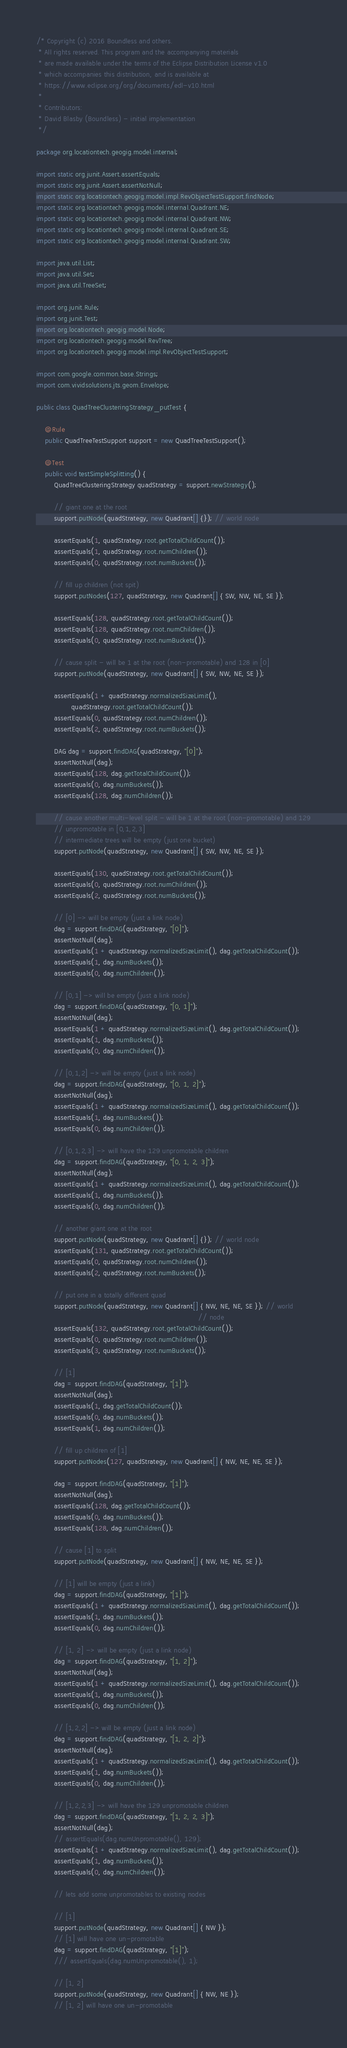<code> <loc_0><loc_0><loc_500><loc_500><_Java_>/* Copyright (c) 2016 Boundless and others.
 * All rights reserved. This program and the accompanying materials
 * are made available under the terms of the Eclipse Distribution License v1.0
 * which accompanies this distribution, and is available at
 * https://www.eclipse.org/org/documents/edl-v10.html
 *
 * Contributors:
 * David Blasby (Boundless) - initial implementation
 */

package org.locationtech.geogig.model.internal;

import static org.junit.Assert.assertEquals;
import static org.junit.Assert.assertNotNull;
import static org.locationtech.geogig.model.impl.RevObjectTestSupport.findNode;
import static org.locationtech.geogig.model.internal.Quadrant.NE;
import static org.locationtech.geogig.model.internal.Quadrant.NW;
import static org.locationtech.geogig.model.internal.Quadrant.SE;
import static org.locationtech.geogig.model.internal.Quadrant.SW;

import java.util.List;
import java.util.Set;
import java.util.TreeSet;

import org.junit.Rule;
import org.junit.Test;
import org.locationtech.geogig.model.Node;
import org.locationtech.geogig.model.RevTree;
import org.locationtech.geogig.model.impl.RevObjectTestSupport;

import com.google.common.base.Strings;
import com.vividsolutions.jts.geom.Envelope;

public class QuadTreeClusteringStrategy_putTest {

    @Rule
    public QuadTreeTestSupport support = new QuadTreeTestSupport();

    @Test
    public void testSimpleSplitting() {
        QuadTreeClusteringStrategy quadStrategy = support.newStrategy();

        // giant one at the root
        support.putNode(quadStrategy, new Quadrant[] {}); // world node

        assertEquals(1, quadStrategy.root.getTotalChildCount());
        assertEquals(1, quadStrategy.root.numChildren());
        assertEquals(0, quadStrategy.root.numBuckets());

        // fill up children (not spit)
        support.putNodes(127, quadStrategy, new Quadrant[] { SW, NW, NE, SE });

        assertEquals(128, quadStrategy.root.getTotalChildCount());
        assertEquals(128, quadStrategy.root.numChildren());
        assertEquals(0, quadStrategy.root.numBuckets());

        // cause split - will be 1 at the root (non-promotable) and 128 in [0]
        support.putNode(quadStrategy, new Quadrant[] { SW, NW, NE, SE });

        assertEquals(1 + quadStrategy.normalizedSizeLimit(),
                quadStrategy.root.getTotalChildCount());
        assertEquals(0, quadStrategy.root.numChildren());
        assertEquals(2, quadStrategy.root.numBuckets());

        DAG dag = support.findDAG(quadStrategy, "[0]");
        assertNotNull(dag);
        assertEquals(128, dag.getTotalChildCount());
        assertEquals(0, dag.numBuckets());
        assertEquals(128, dag.numChildren());

        // cause another multi-level split - will be 1 at the root (non-promotable) and 129
        // unpromotable in [0,1,2,3]
        // intermediate trees will be empty (just one bucket)
        support.putNode(quadStrategy, new Quadrant[] { SW, NW, NE, SE });

        assertEquals(130, quadStrategy.root.getTotalChildCount());
        assertEquals(0, quadStrategy.root.numChildren());
        assertEquals(2, quadStrategy.root.numBuckets());

        // [0] -> will be empty (just a link node)
        dag = support.findDAG(quadStrategy, "[0]");
        assertNotNull(dag);
        assertEquals(1 + quadStrategy.normalizedSizeLimit(), dag.getTotalChildCount());
        assertEquals(1, dag.numBuckets());
        assertEquals(0, dag.numChildren());

        // [0,1] -> will be empty (just a link node)
        dag = support.findDAG(quadStrategy, "[0, 1]");
        assertNotNull(dag);
        assertEquals(1 + quadStrategy.normalizedSizeLimit(), dag.getTotalChildCount());
        assertEquals(1, dag.numBuckets());
        assertEquals(0, dag.numChildren());

        // [0,1,2] -> will be empty (just a link node)
        dag = support.findDAG(quadStrategy, "[0, 1, 2]");
        assertNotNull(dag);
        assertEquals(1 + quadStrategy.normalizedSizeLimit(), dag.getTotalChildCount());
        assertEquals(1, dag.numBuckets());
        assertEquals(0, dag.numChildren());

        // [0,1,2,3] -> will have the 129 unpromotable children
        dag = support.findDAG(quadStrategy, "[0, 1, 2, 3]");
        assertNotNull(dag);
        assertEquals(1 + quadStrategy.normalizedSizeLimit(), dag.getTotalChildCount());
        assertEquals(1, dag.numBuckets());
        assertEquals(0, dag.numChildren());

        // another giant one at the root
        support.putNode(quadStrategy, new Quadrant[] {}); // world node
        assertEquals(131, quadStrategy.root.getTotalChildCount());
        assertEquals(0, quadStrategy.root.numChildren());
        assertEquals(2, quadStrategy.root.numBuckets());

        // put one in a totally different quad
        support.putNode(quadStrategy, new Quadrant[] { NW, NE, NE, SE }); // world
                                                                          // node
        assertEquals(132, quadStrategy.root.getTotalChildCount());
        assertEquals(0, quadStrategy.root.numChildren());
        assertEquals(3, quadStrategy.root.numBuckets());

        // [1]
        dag = support.findDAG(quadStrategy, "[1]");
        assertNotNull(dag);
        assertEquals(1, dag.getTotalChildCount());
        assertEquals(0, dag.numBuckets());
        assertEquals(1, dag.numChildren());

        // fill up children of [1]
        support.putNodes(127, quadStrategy, new Quadrant[] { NW, NE, NE, SE });

        dag = support.findDAG(quadStrategy, "[1]");
        assertNotNull(dag);
        assertEquals(128, dag.getTotalChildCount());
        assertEquals(0, dag.numBuckets());
        assertEquals(128, dag.numChildren());

        // cause [1] to split
        support.putNode(quadStrategy, new Quadrant[] { NW, NE, NE, SE });

        // [1] will be empty (just a link)
        dag = support.findDAG(quadStrategy, "[1]");
        assertEquals(1 + quadStrategy.normalizedSizeLimit(), dag.getTotalChildCount());
        assertEquals(1, dag.numBuckets());
        assertEquals(0, dag.numChildren());

        // [1, 2] -> will be empty (just a link node)
        dag = support.findDAG(quadStrategy, "[1, 2]");
        assertNotNull(dag);
        assertEquals(1 + quadStrategy.normalizedSizeLimit(), dag.getTotalChildCount());
        assertEquals(1, dag.numBuckets());
        assertEquals(0, dag.numChildren());

        // [1,2,2] -> will be empty (just a link node)
        dag = support.findDAG(quadStrategy, "[1, 2, 2]");
        assertNotNull(dag);
        assertEquals(1 + quadStrategy.normalizedSizeLimit(), dag.getTotalChildCount());
        assertEquals(1, dag.numBuckets());
        assertEquals(0, dag.numChildren());

        // [1,2,2,3] -> will have the 129 unpromotable children
        dag = support.findDAG(quadStrategy, "[1, 2, 2, 3]");
        assertNotNull(dag);
        // assertEquals(dag.numUnpromotable(), 129);
        assertEquals(1 + quadStrategy.normalizedSizeLimit(), dag.getTotalChildCount());
        assertEquals(1, dag.numBuckets());
        assertEquals(0, dag.numChildren());

        // lets add some unpromotables to existing nodes

        // [1]
        support.putNode(quadStrategy, new Quadrant[] { NW });
        // [1] will have one un-promotable
        dag = support.findDAG(quadStrategy, "[1]");
        /// assertEquals(dag.numUnpromotable(), 1);

        // [1, 2]
        support.putNode(quadStrategy, new Quadrant[] { NW, NE });
        // [1, 2] will have one un-promotable</code> 